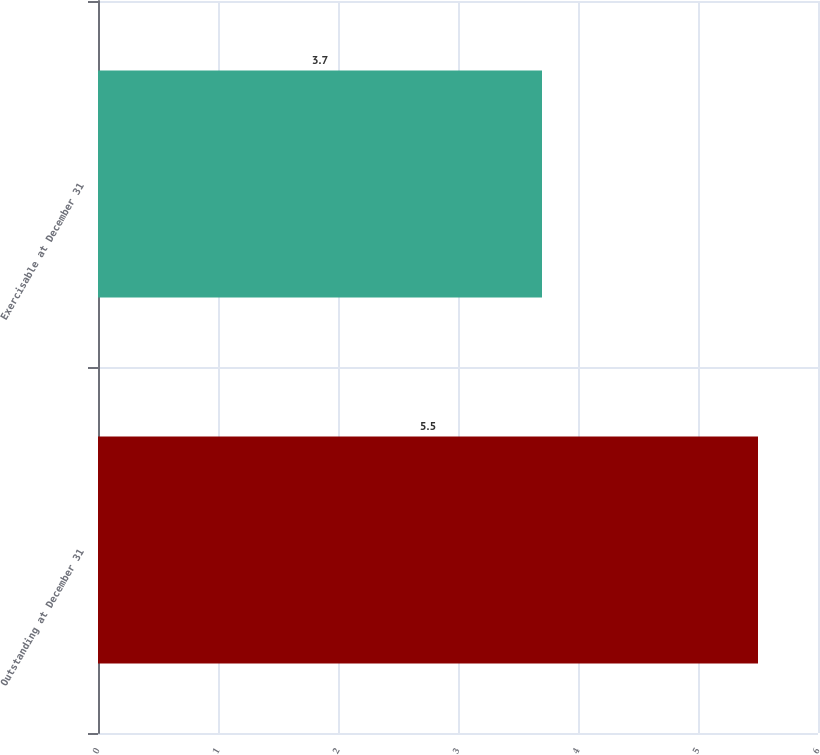<chart> <loc_0><loc_0><loc_500><loc_500><bar_chart><fcel>Outstanding at December 31<fcel>Exercisable at December 31<nl><fcel>5.5<fcel>3.7<nl></chart> 